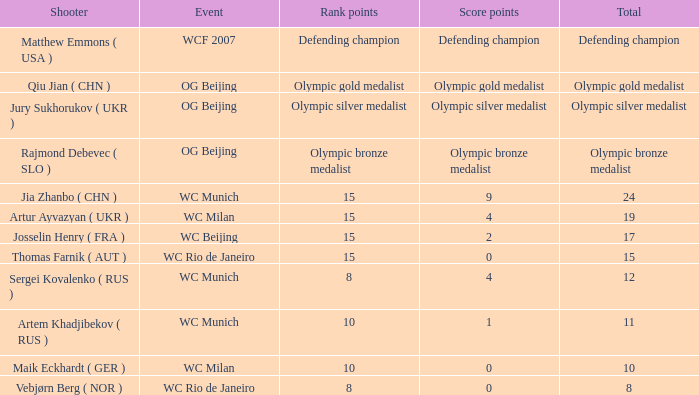With a total of 11, what is the score points? 1.0. 